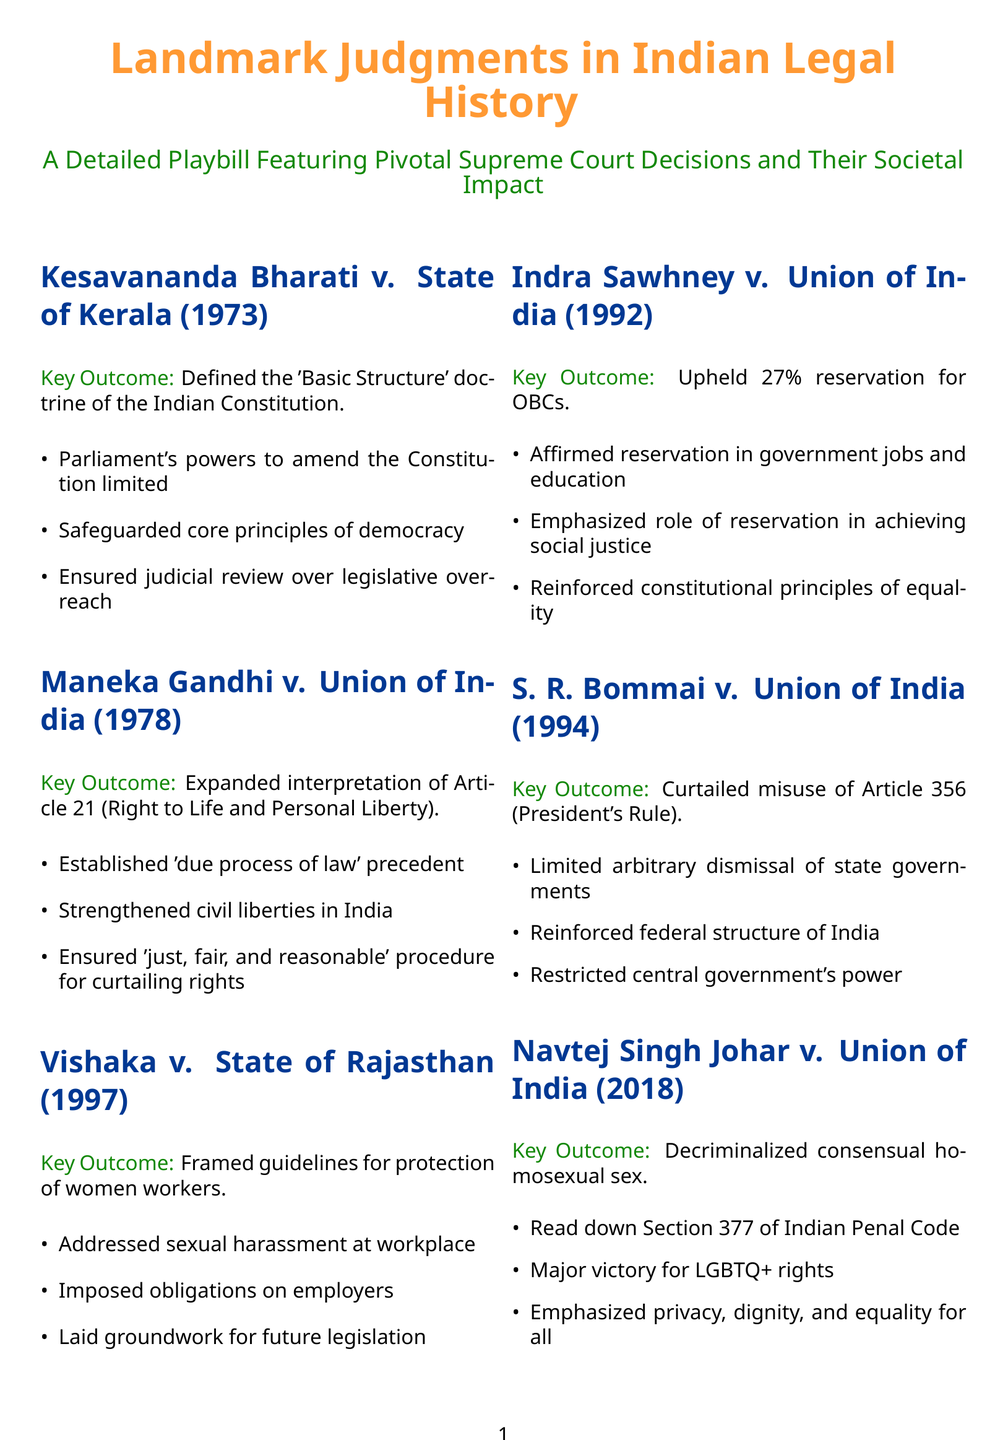What is the title of the document? The title of the document is prominently displayed at the top, identifying its focus on landmark judgments in India.
Answer: Landmark Judgments in Indian Legal History How many key judgments are mentioned in the playbill? Each section outlines a judgment, and there are six distinct sections covering judgments.
Answer: 6 Which judgment defined the 'Basic Structure' doctrine? The specific judgment that defined this concept is indicated in its dedicated section.
Answer: Kesavananda Bharati v. State of Kerala In which year was the Maneka Gandhi case decided? The decision year is provided alongside the case name in the document.
Answer: 1978 What key principle was established in the Vishaka case? The document highlights the primary focus of the ruling within its summary.
Answer: Guidelines for protection of women workers Which article of the Constitution was expanded through the Maneka Gandhi case? This detail is referenced directly in the summary of the case's key outcomes.
Answer: Article 21 What percentage of reservation for OBCs was upheld in Indra Sawhney v. Union of India? The specific percentage of reservation is mentioned in the outcomes of this judgment.
Answer: 27% What societal group was primarily impacted by the Navtej Singh Johar decision? The document specifies the group concerning the key outcome of this landmark case.
Answer: LGBTQ+ rights What is the color scheme used for the headings in the playbill? The headings are distinctly colored, which is noted in the document for clarity and emphasis.
Answer: Navy 